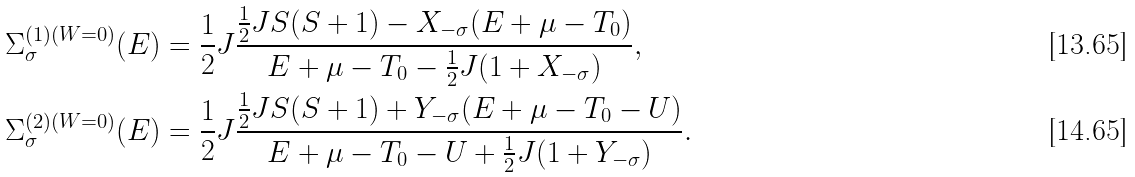Convert formula to latex. <formula><loc_0><loc_0><loc_500><loc_500>\Sigma _ { \sigma } ^ { ( 1 ) ( W = 0 ) } ( E ) & = \frac { 1 } { 2 } J \frac { \frac { 1 } { 2 } J S ( S + 1 ) - X _ { - \sigma } ( E + \mu - T _ { 0 } ) } { E + \mu - T _ { 0 } - \frac { 1 } { 2 } J ( 1 + X _ { - \sigma } ) } , \\ \Sigma _ { \sigma } ^ { ( 2 ) ( W = 0 ) } ( E ) & = \frac { 1 } { 2 } J \frac { \frac { 1 } { 2 } J S ( S + 1 ) + Y _ { - \sigma } ( E + \mu - T _ { 0 } - U ) } { E + \mu - T _ { 0 } - U + \frac { 1 } { 2 } J ( 1 + Y _ { - \sigma } ) } .</formula> 